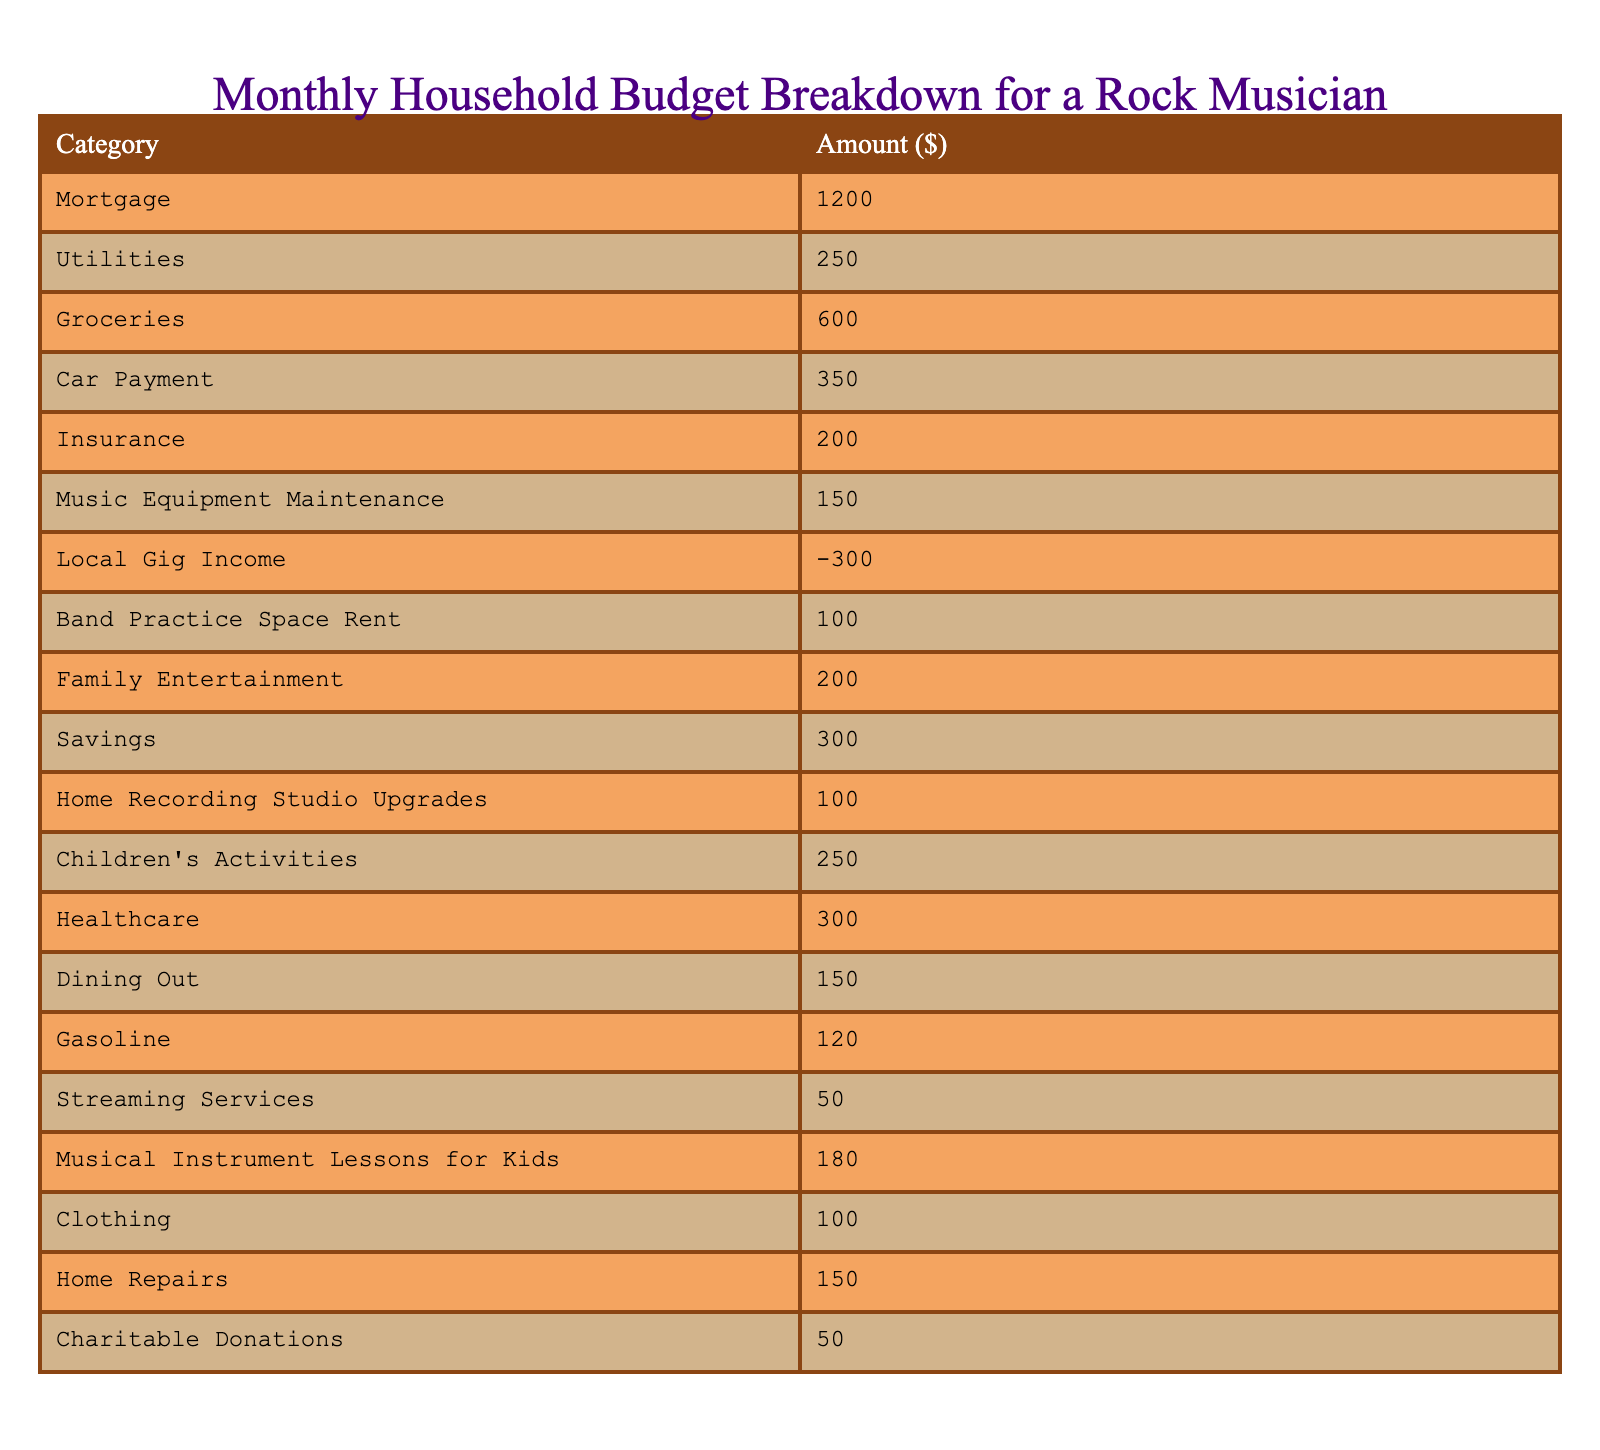What is the total amount spent on groceries and dining out? The amount spent on groceries is 600, and the amount spent on dining out is 150. To find the total, I add these two amounts: 600 + 150 = 750.
Answer: 750 What is the amount allocated to insurance? The insurance amount listed in the table is directly stated as 200.
Answer: 200 Is the music equipment maintenance expense more than the local gig income? The music equipment maintenance expense is 150, while the local gig income is -300. Since 150 is greater than -300, the statement is true.
Answer: Yes What is the net amount for family entertainment minus insurance? The amount allocated for family entertainment is 200, and insurance is 200 as well. To find the net amount, subtract insurance from family entertainment: 200 - 200 = 0.
Answer: 0 What are the total expenditures for children's activities and healthcare? The amount for children's activities is 250, and healthcare costs 300. Adding both amounts together gives: 250 + 300 = 550.
Answer: 550 Is the cost for streaming services greater than the amount spent on clothing? Streaming services cost 50, and clothing costs 100. Since 50 is not greater than 100, the statement is false.
Answer: No What is the total amount spent on gas and utilities combined? The gas amount is 120, and utilities amount to 250. When adding these, I get: 120 + 250 = 370.
Answer: 370 How much did the musician spend on home repairs compared to savings? The musician spent 150 on home repairs and allocated 300 for savings. Since 150 is less than 300, the spending on home repairs is lower than savings.
Answer: 150 is less than 300 